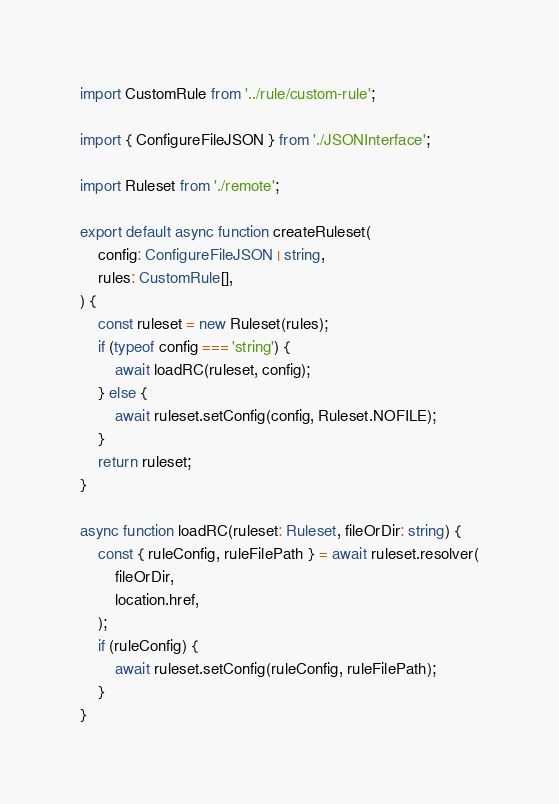Convert code to text. <code><loc_0><loc_0><loc_500><loc_500><_TypeScript_>import CustomRule from '../rule/custom-rule';

import { ConfigureFileJSON } from './JSONInterface';

import Ruleset from './remote';

export default async function createRuleset(
	config: ConfigureFileJSON | string,
	rules: CustomRule[],
) {
	const ruleset = new Ruleset(rules);
	if (typeof config === 'string') {
		await loadRC(ruleset, config);
	} else {
		await ruleset.setConfig(config, Ruleset.NOFILE);
	}
	return ruleset;
}

async function loadRC(ruleset: Ruleset, fileOrDir: string) {
	const { ruleConfig, ruleFilePath } = await ruleset.resolver(
		fileOrDir,
		location.href,
	);
	if (ruleConfig) {
		await ruleset.setConfig(ruleConfig, ruleFilePath);
	}
}
</code> 